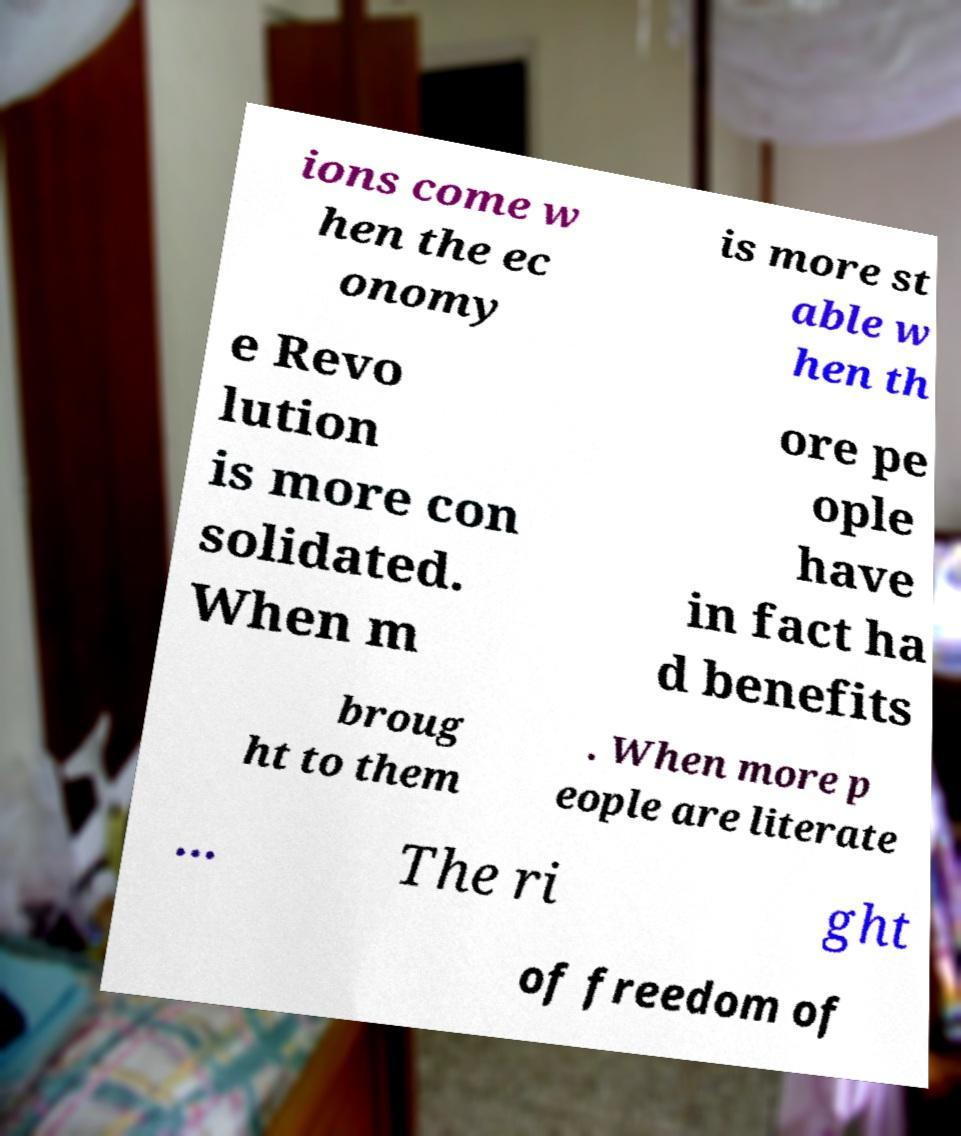For documentation purposes, I need the text within this image transcribed. Could you provide that? ions come w hen the ec onomy is more st able w hen th e Revo lution is more con solidated. When m ore pe ople have in fact ha d benefits broug ht to them . When more p eople are literate ... The ri ght of freedom of 